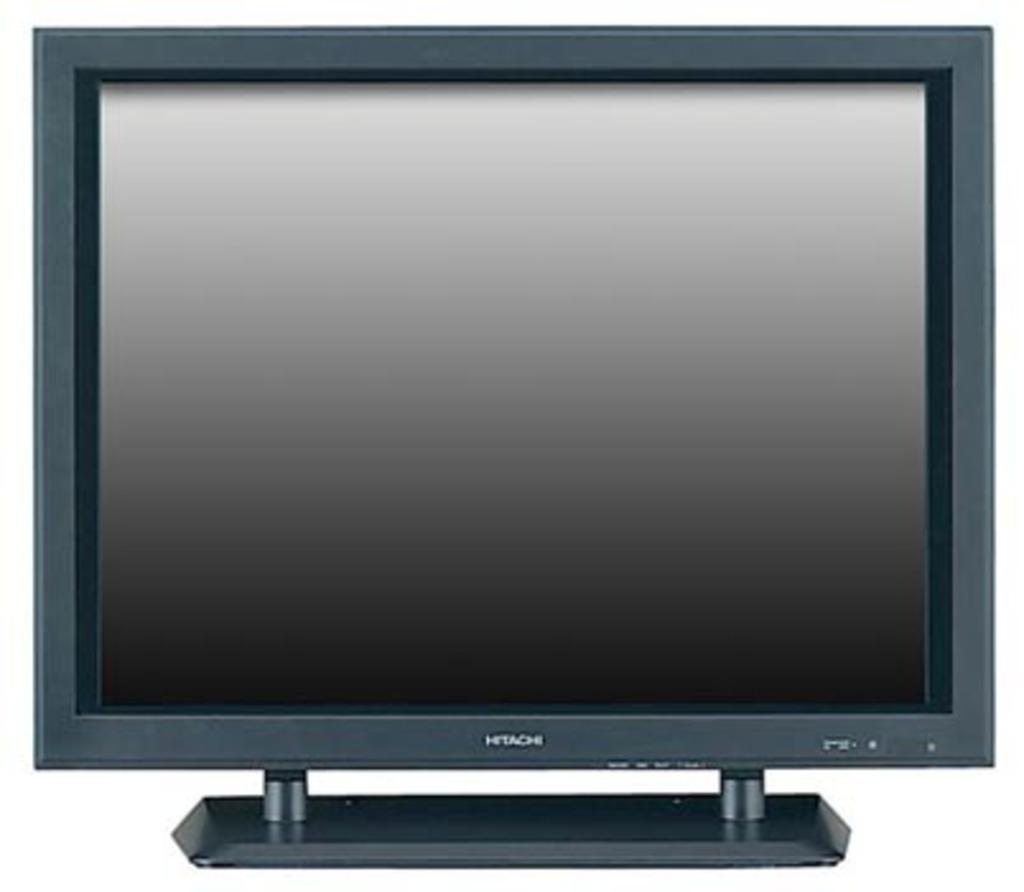<image>
Present a compact description of the photo's key features. A turned off Hitatchi monitor not hooked up to anything. 